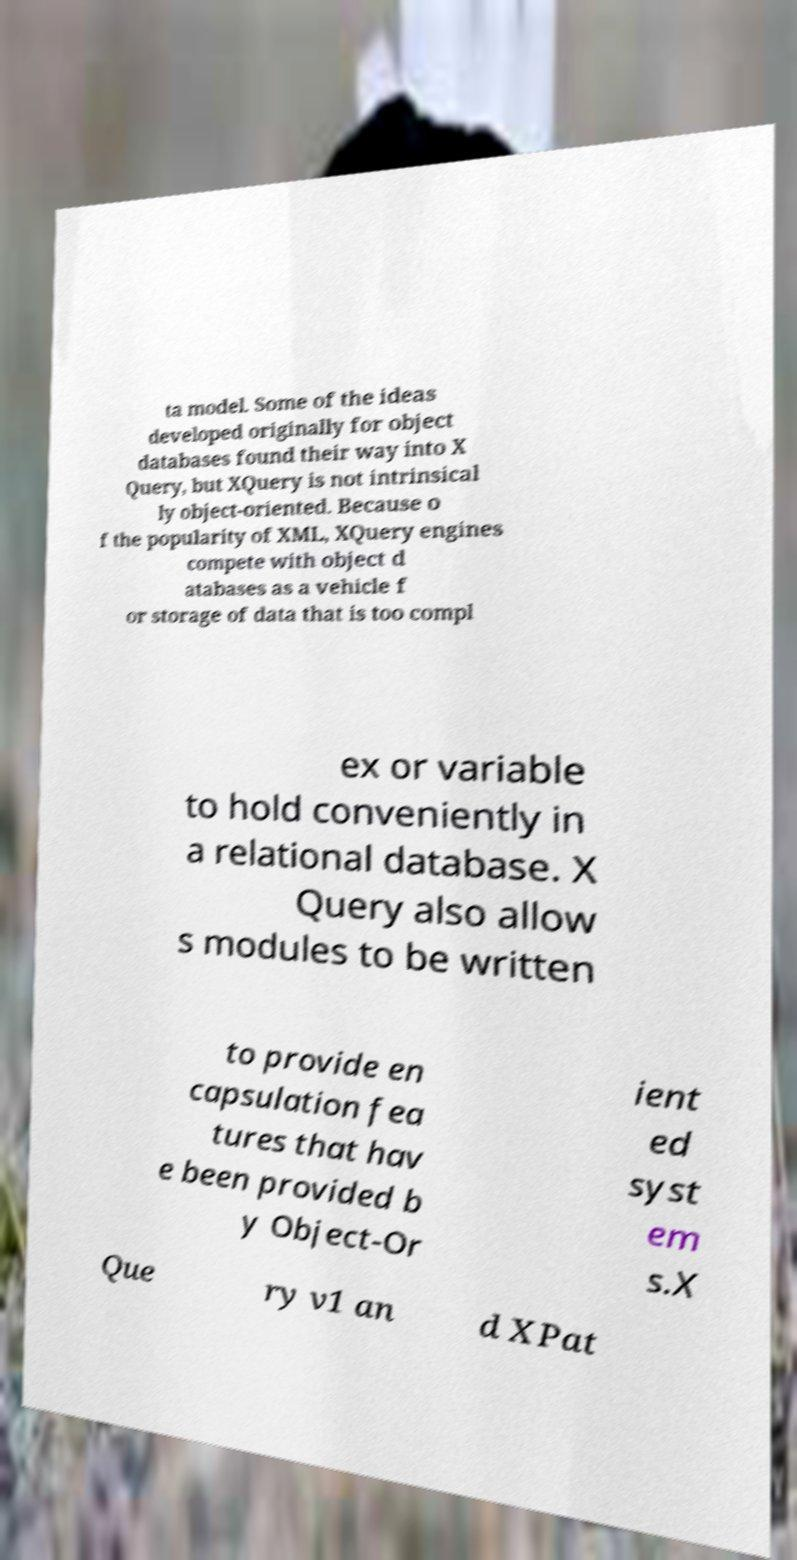Please read and relay the text visible in this image. What does it say? ta model. Some of the ideas developed originally for object databases found their way into X Query, but XQuery is not intrinsical ly object-oriented. Because o f the popularity of XML, XQuery engines compete with object d atabases as a vehicle f or storage of data that is too compl ex or variable to hold conveniently in a relational database. X Query also allow s modules to be written to provide en capsulation fea tures that hav e been provided b y Object-Or ient ed syst em s.X Que ry v1 an d XPat 